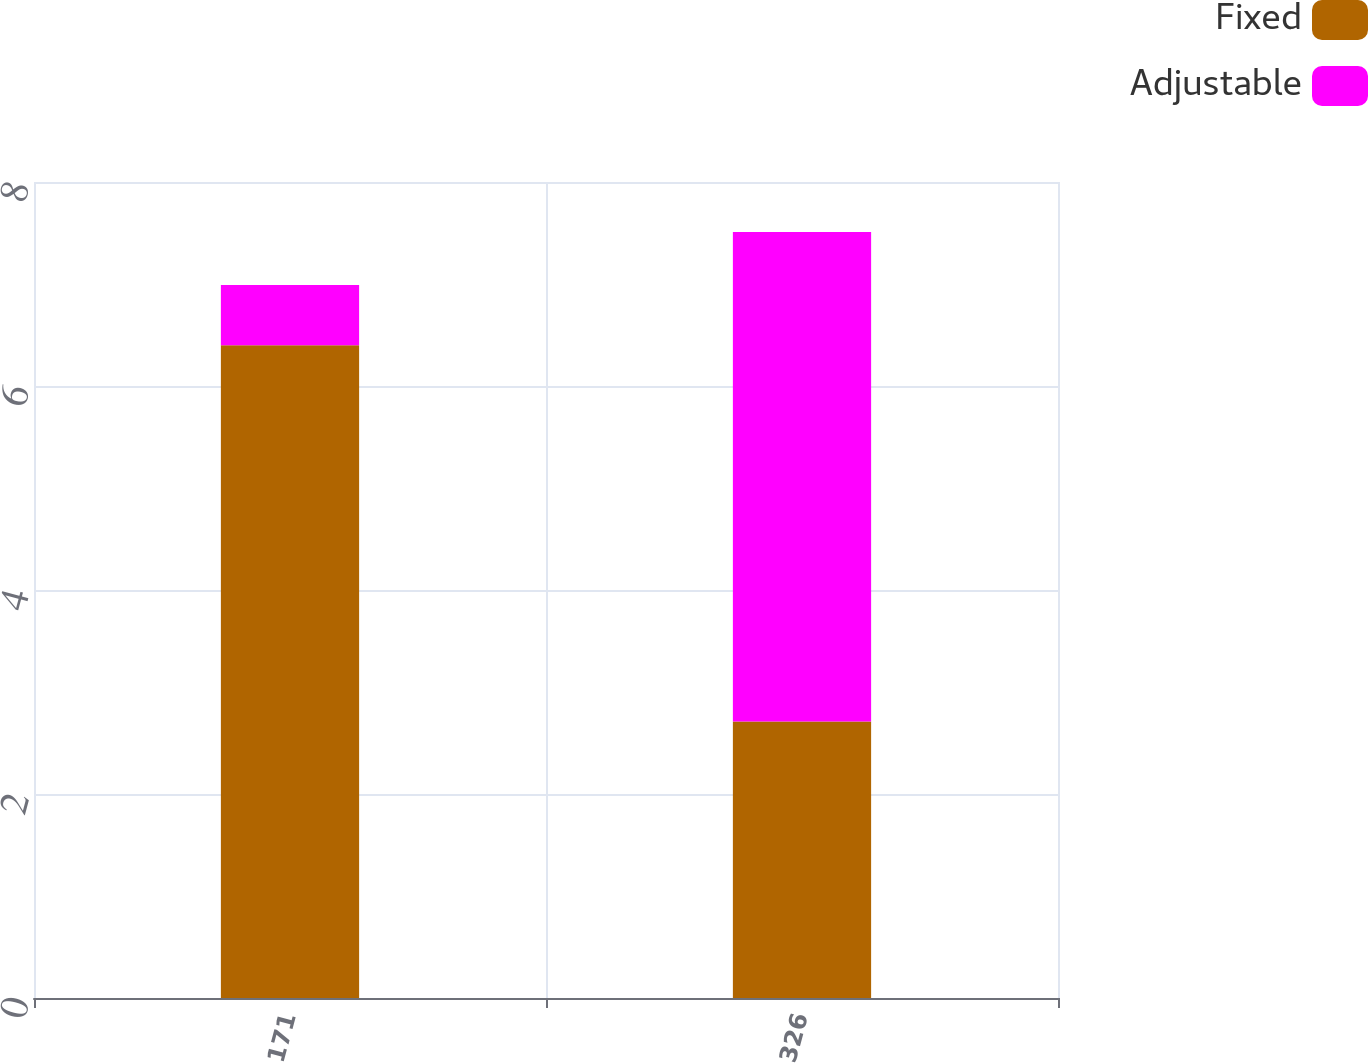Convert chart. <chart><loc_0><loc_0><loc_500><loc_500><stacked_bar_chart><ecel><fcel>171<fcel>326<nl><fcel>Fixed<fcel>6.4<fcel>2.71<nl><fcel>Adjustable<fcel>0.59<fcel>4.8<nl></chart> 